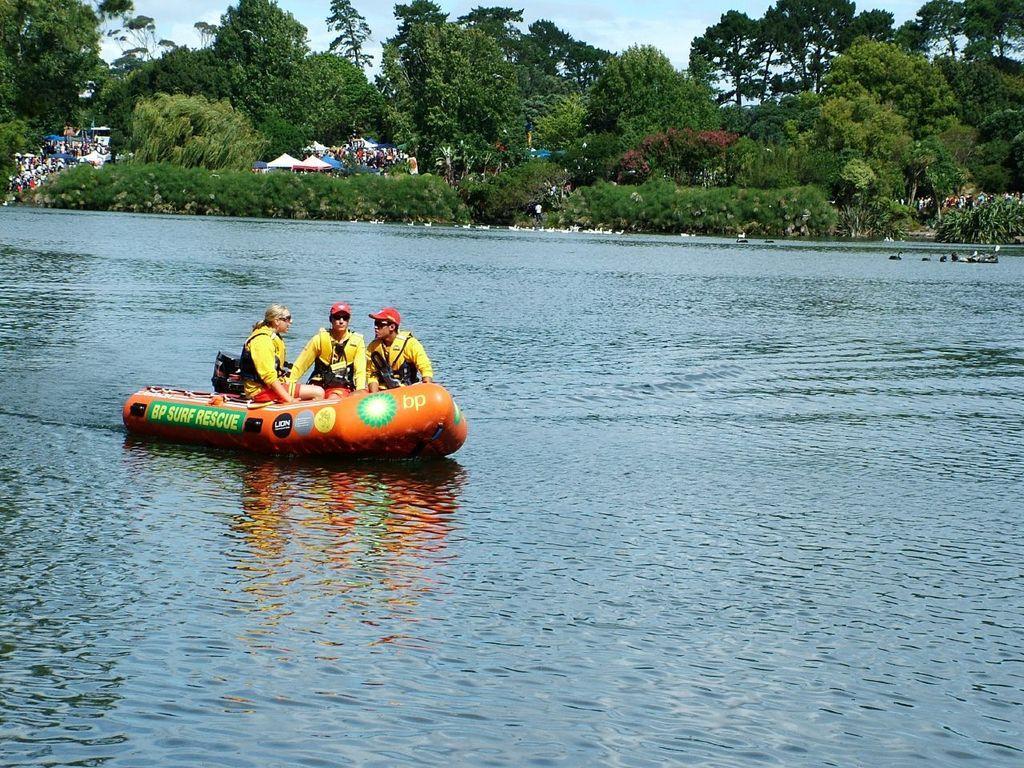Could you give a brief overview of what you see in this image? In this picture I can observe a boat floating on the water. There are three members sitting in the boat. Two of them are wearing red color caps on their heads. In the background there are plants and trees on the ground. I can observe a sky with some clouds in the background. 